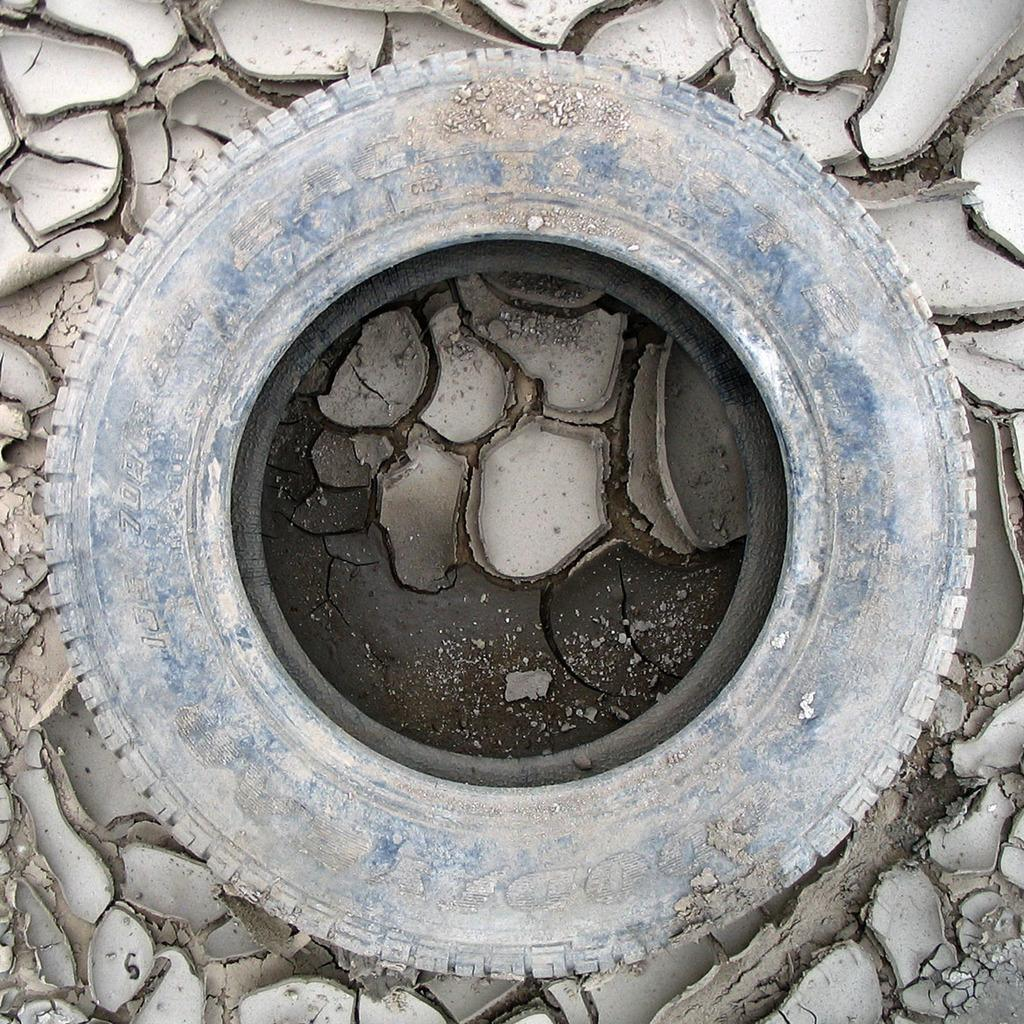What object is present in the image? There is a tire in the image. What is the color of the tire? The tire is ash and black in color. Where is the tire located? The tire is on the ground. What is the condition of the tire? The tire is broken into small pieces. What is the color of the small pieces? The small pieces are cream in color. What type of shoes can be seen in the image? There are no shoes present in the image; it features a broken tire. What is the value of the cork in the image? There is no cork present in the image, so it is not possible to determine its value. 